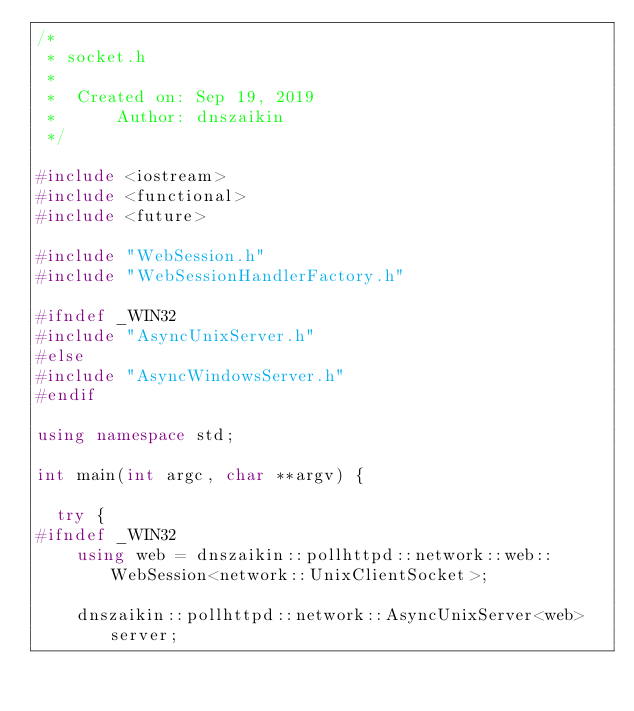Convert code to text. <code><loc_0><loc_0><loc_500><loc_500><_C++_>/*
 * socket.h
 *
 *  Created on: Sep 19, 2019
 *      Author: dnszaikin
 */

#include <iostream>
#include <functional>
#include <future>

#include "WebSession.h"
#include "WebSessionHandlerFactory.h"

#ifndef _WIN32
#include "AsyncUnixServer.h"
#else
#include "AsyncWindowsServer.h"
#endif

using namespace std;

int main(int argc, char **argv) {

	try {
#ifndef _WIN32
		using web = dnszaikin::pollhttpd::network::web::WebSession<network::UnixClientSocket>;

		dnszaikin::pollhttpd::network::AsyncUnixServer<web> server;
</code> 